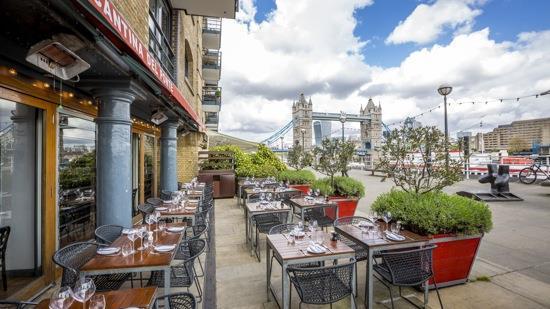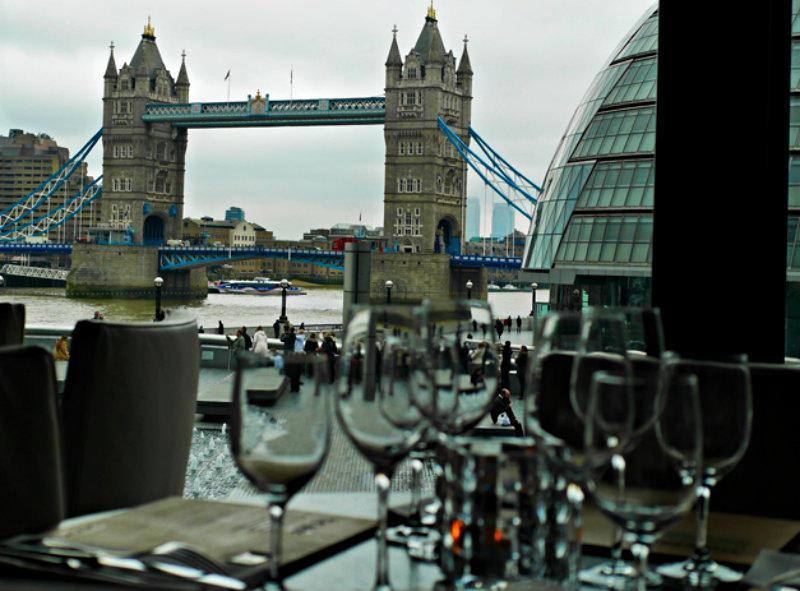The first image is the image on the left, the second image is the image on the right. Analyze the images presented: Is the assertion "The right image shows an open-air rooftop dining area with a background of a span bridge featuring two square columns with castle-like tops." valid? Answer yes or no. Yes. 